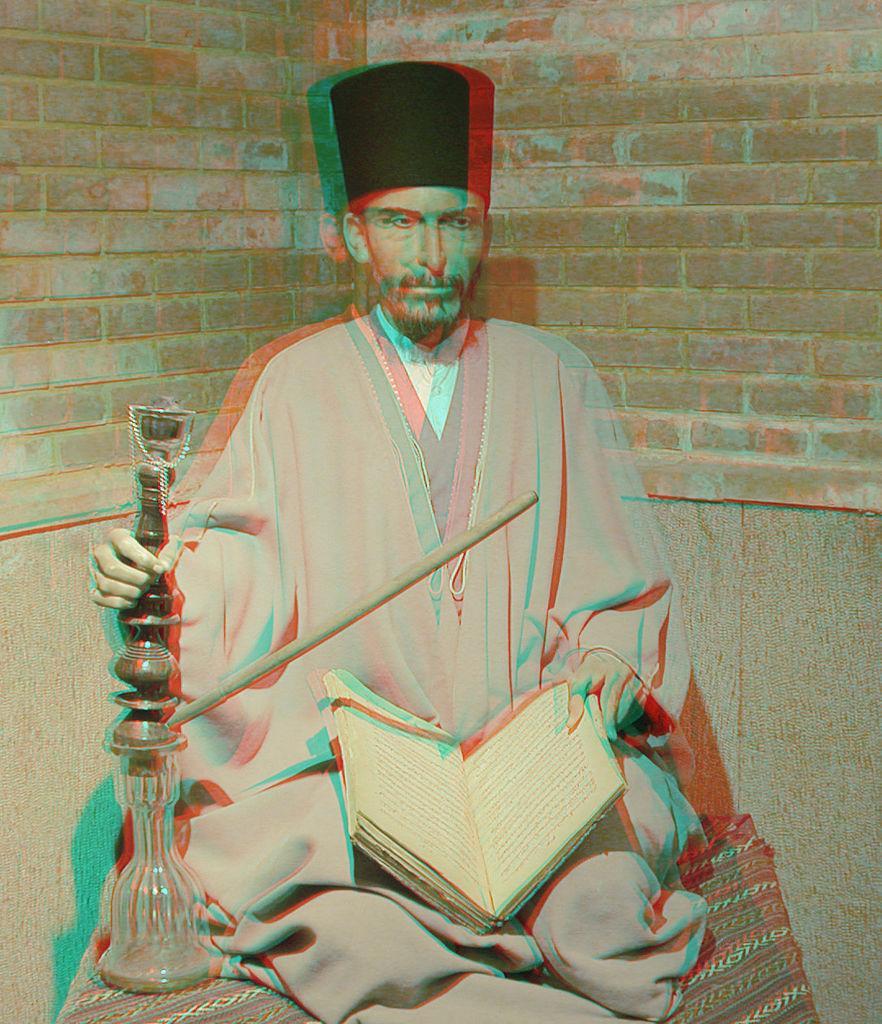Can you describe this image briefly? In the image there is a man sitting on the cloth and holding the book in his hand. And in other hand there is a hookah with pipe. Behind him there is a brick wall. 